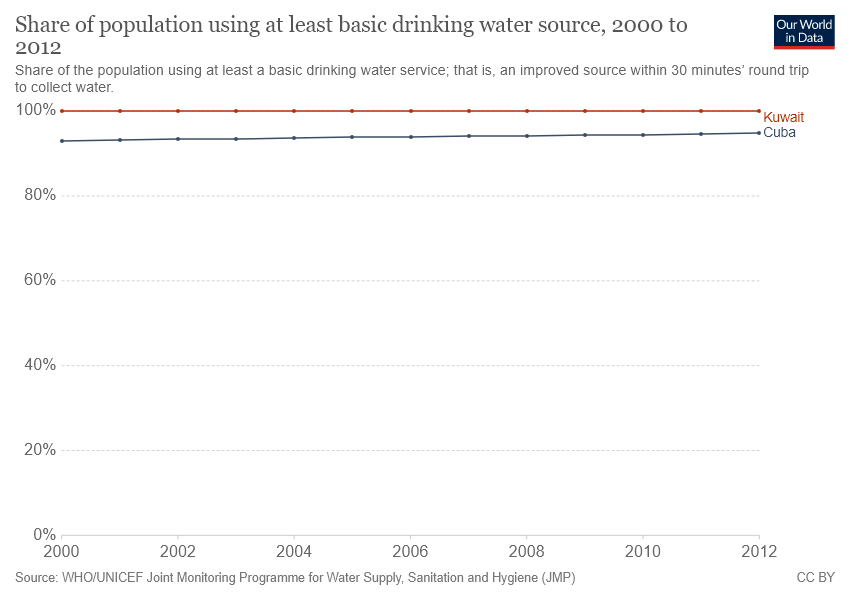Indicate a few pertinent items in this graphic. The given line graph compares the literacy rates of two countries, Kuwait and Cuba, over a period of 30 years. Kuwait has a higher share of its population using at least a basic drinking water source compared to Cuba, according to the given information. 